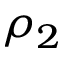Convert formula to latex. <formula><loc_0><loc_0><loc_500><loc_500>\rho _ { 2 }</formula> 